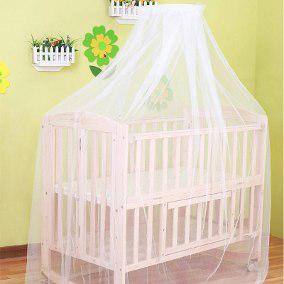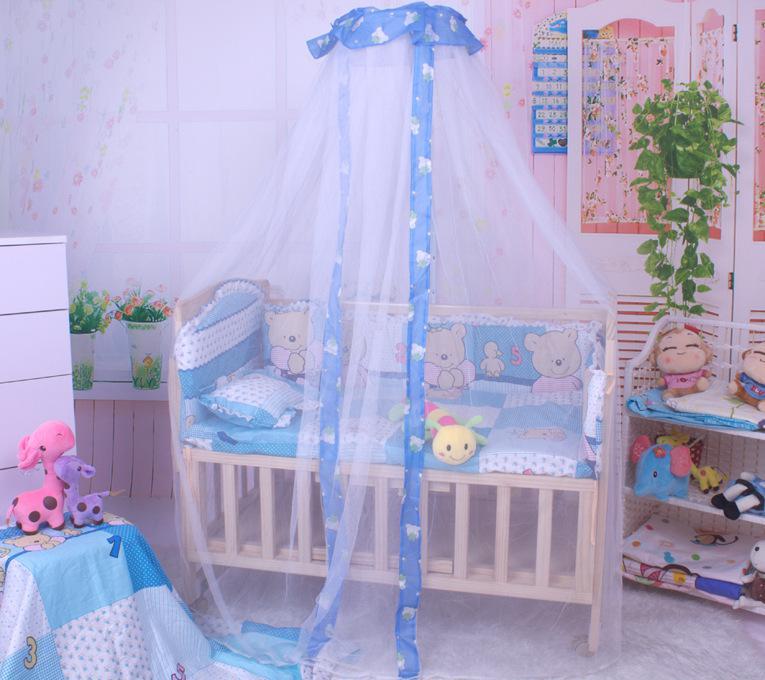The first image is the image on the left, the second image is the image on the right. Evaluate the accuracy of this statement regarding the images: "There is a stuffed animal in the left image.". Is it true? Answer yes or no. No. 